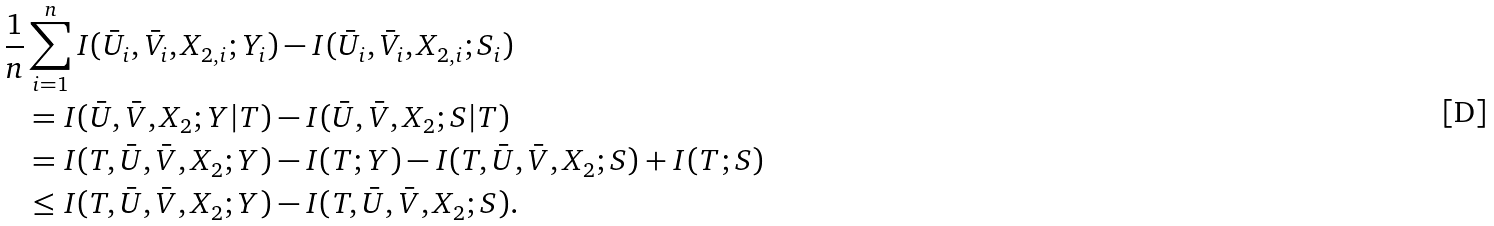Convert formula to latex. <formula><loc_0><loc_0><loc_500><loc_500>\frac { 1 } { n } & \sum _ { i = 1 } ^ { n } I ( \bar { U } _ { i } , \bar { V } _ { i } , X _ { 2 , i } ; Y _ { i } ) - I ( \bar { U } _ { i } , \bar { V } _ { i } , X _ { 2 , i } ; S _ { i } ) \\ & = I ( \bar { U } , \bar { V } , X _ { 2 } ; Y | T ) - I ( \bar { U } , \bar { V } , X _ { 2 } ; S | T ) \\ & = I ( T , \bar { U } , \bar { V } , X _ { 2 } ; Y ) - I ( T ; Y ) - I ( T , \bar { U } , \bar { V } , X _ { 2 } ; S ) + I ( T ; S ) \\ & \leq I ( T , \bar { U } , \bar { V } , X _ { 2 } ; Y ) - I ( T , \bar { U } , \bar { V } , X _ { 2 } ; S ) .</formula> 